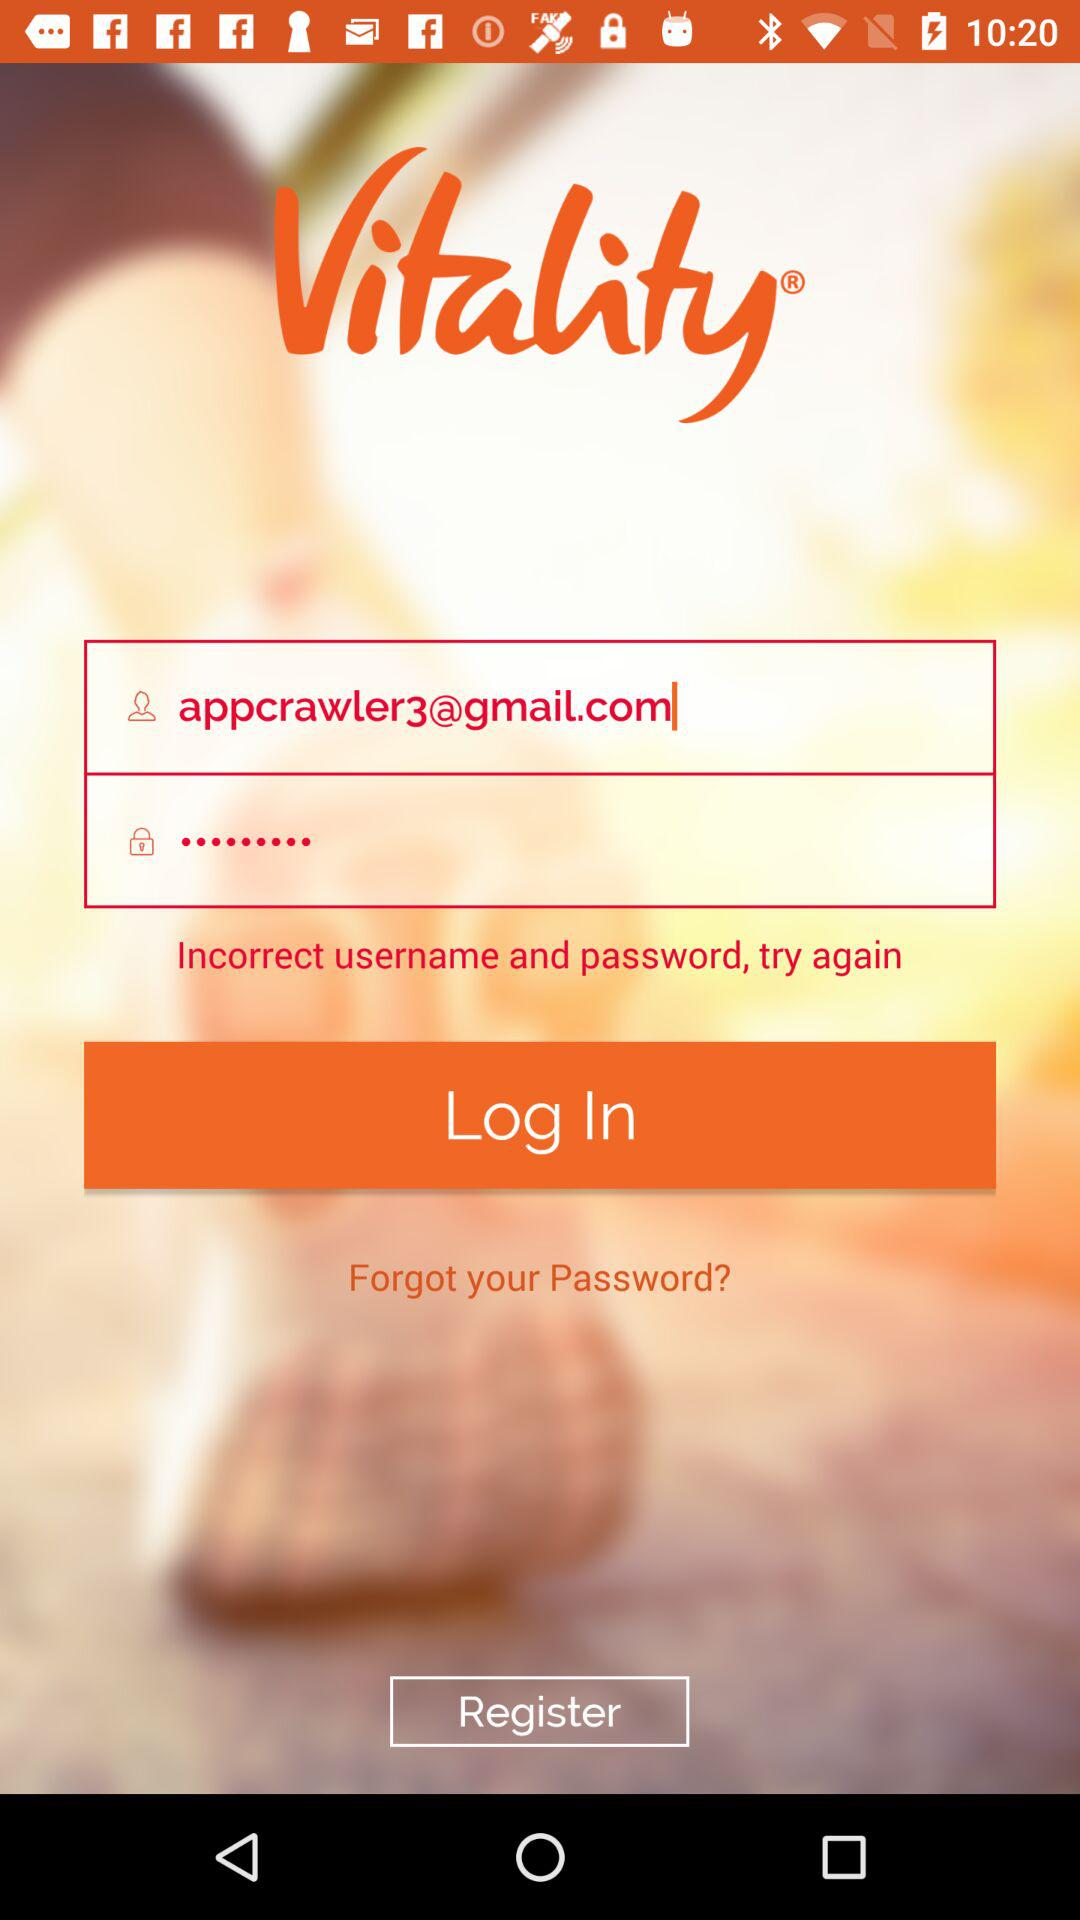What is the app name? The app name is "Vitality". 